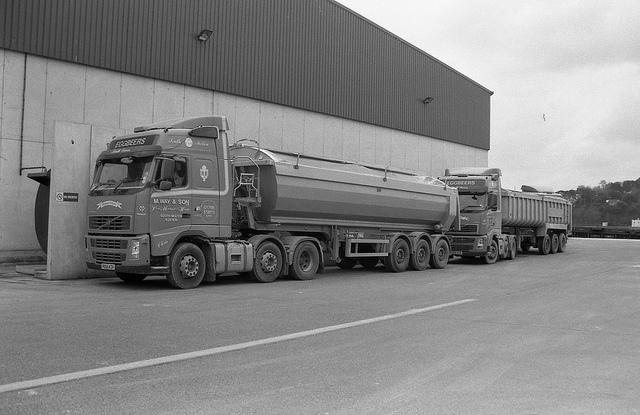Is this a train station?
Quick response, please. No. Is the truck on the road?
Be succinct. No. What is the proper term for several buses driving in tandem?
Concise answer only. Convoy. How many trucks are outside?
Give a very brief answer. 2. What kind truck is this?
Answer briefly. Tanker. What color is the sky near the clouds?
Quick response, please. Gray. Can you see any red in the photo?
Short answer required. No. How many wheels are visible?
Write a very short answer. 12. What do these vehicles transport?
Keep it brief. Gas. 